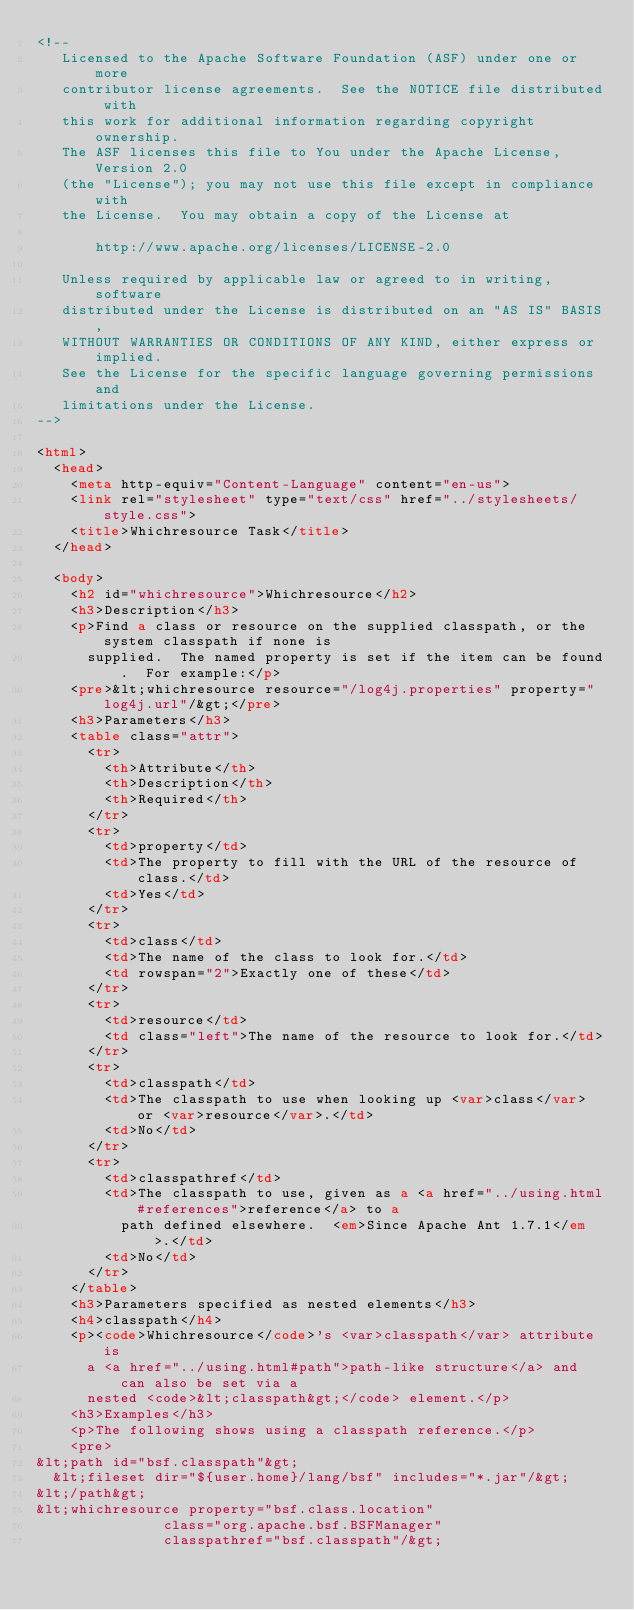Convert code to text. <code><loc_0><loc_0><loc_500><loc_500><_HTML_><!--
   Licensed to the Apache Software Foundation (ASF) under one or more
   contributor license agreements.  See the NOTICE file distributed with
   this work for additional information regarding copyright ownership.
   The ASF licenses this file to You under the Apache License, Version 2.0
   (the "License"); you may not use this file except in compliance with
   the License.  You may obtain a copy of the License at

       http://www.apache.org/licenses/LICENSE-2.0

   Unless required by applicable law or agreed to in writing, software
   distributed under the License is distributed on an "AS IS" BASIS,
   WITHOUT WARRANTIES OR CONDITIONS OF ANY KIND, either express or implied.
   See the License for the specific language governing permissions and
   limitations under the License.
-->

<html>
  <head>
    <meta http-equiv="Content-Language" content="en-us">
    <link rel="stylesheet" type="text/css" href="../stylesheets/style.css">
    <title>Whichresource Task</title>
  </head>

  <body>
    <h2 id="whichresource">Whichresource</h2>
    <h3>Description</h3>
    <p>Find a class or resource on the supplied classpath, or the system classpath if none is
      supplied.  The named property is set if the item can be found.  For example:</p>
    <pre>&lt;whichresource resource="/log4j.properties" property="log4j.url"/&gt;</pre>
    <h3>Parameters</h3>
    <table class="attr">
      <tr>
        <th>Attribute</th>
        <th>Description</th>
        <th>Required</th>
      </tr>
      <tr>
        <td>property</td>
        <td>The property to fill with the URL of the resource of class.</td>
        <td>Yes</td>
      </tr>
      <tr>
        <td>class</td>
        <td>The name of the class to look for.</td>
        <td rowspan="2">Exactly one of these</td>
      </tr>
      <tr>
        <td>resource</td>
        <td class="left">The name of the resource to look for.</td>
      </tr>
      <tr>
        <td>classpath</td>
        <td>The classpath to use when looking up <var>class</var> or <var>resource</var>.</td>
        <td>No</td>
      </tr>
      <tr>
        <td>classpathref</td>
        <td>The classpath to use, given as a <a href="../using.html#references">reference</a> to a
          path defined elsewhere.  <em>Since Apache Ant 1.7.1</em>.</td>
        <td>No</td>
      </tr>
    </table>
    <h3>Parameters specified as nested elements</h3>
    <h4>classpath</h4>
    <p><code>Whichresource</code>'s <var>classpath</var> attribute is
      a <a href="../using.html#path">path-like structure</a> and can also be set via a
      nested <code>&lt;classpath&gt;</code> element.</p>
    <h3>Examples</h3>
    <p>The following shows using a classpath reference.</p>
    <pre>
&lt;path id="bsf.classpath"&gt;
  &lt;fileset dir="${user.home}/lang/bsf" includes="*.jar"/&gt;
&lt;/path&gt;
&lt;whichresource property="bsf.class.location"
               class="org.apache.bsf.BSFManager"
               classpathref="bsf.classpath"/&gt;</code> 